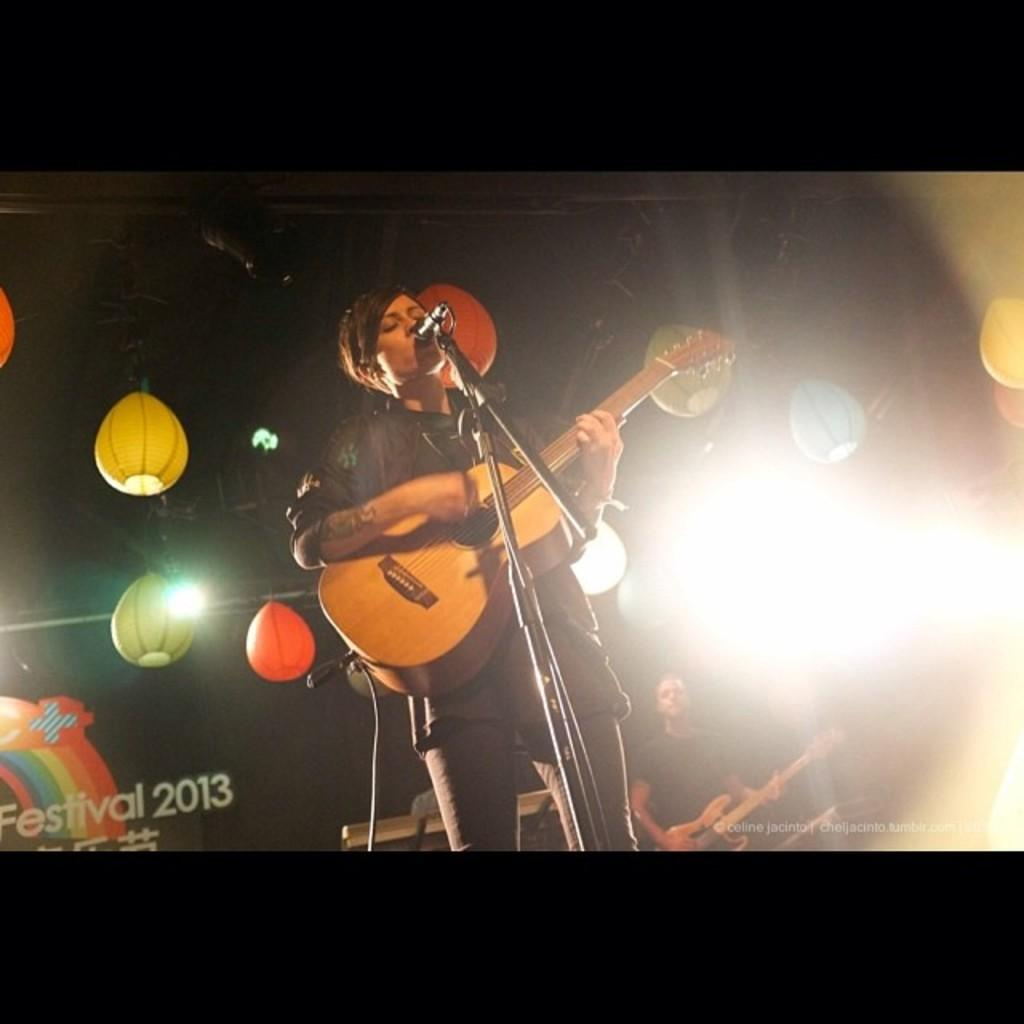Who is the main subject in the image? There is a woman in the image. What is the woman doing in the image? The woman is standing and singing. What is the woman holding in her hand? The woman is holding a guitar in her hand. What can be seen in the background of the image? There are lights visible in the background. How much profit did the woman make from her performance in the image? There is no information about profit in the image, as it focuses on the woman's actions and the presence of a guitar and lights. 